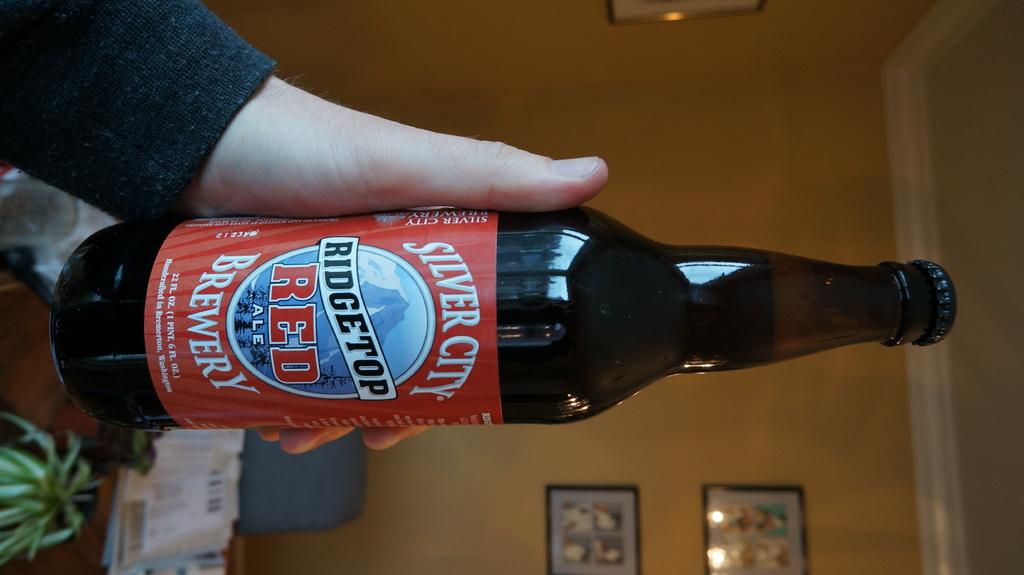What is in the bottle?
Provide a succinct answer. Ale. How many ounces is this beer?
Provide a succinct answer. 22. 